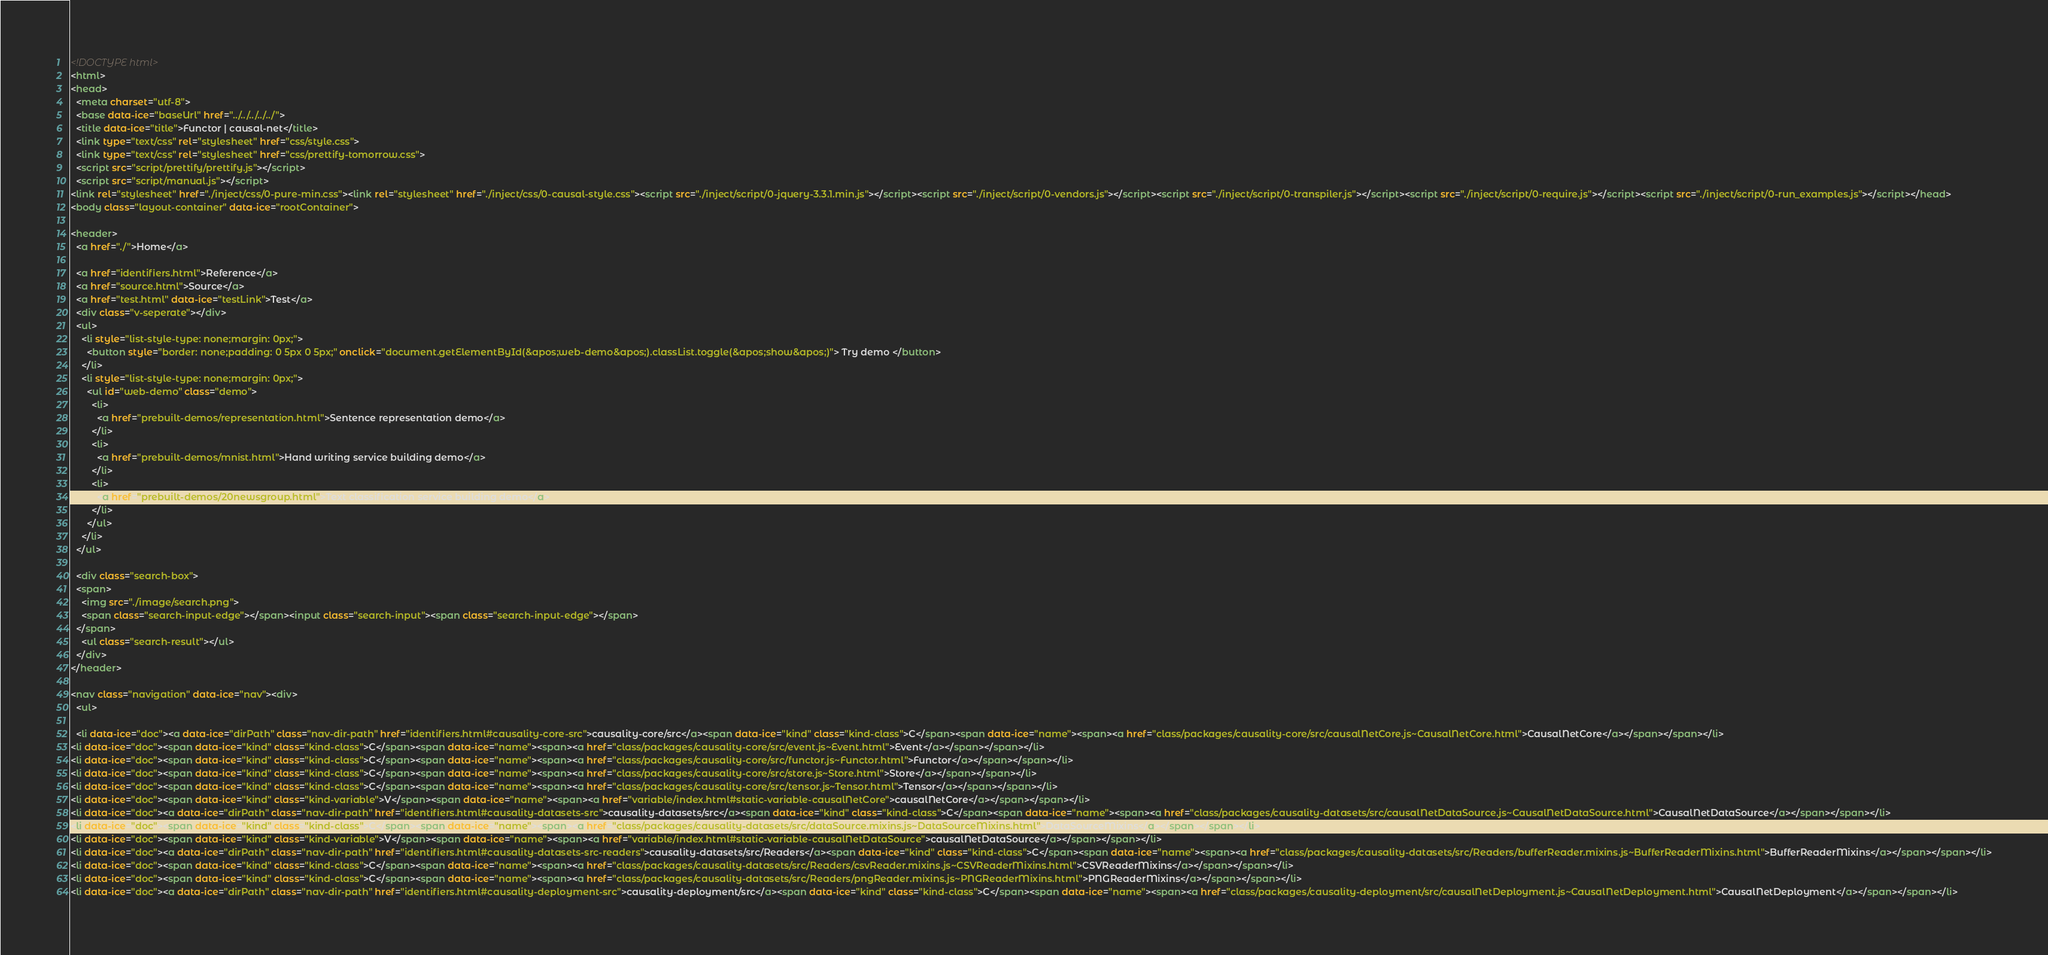<code> <loc_0><loc_0><loc_500><loc_500><_HTML_><!DOCTYPE html>
<html>
<head>
  <meta charset="utf-8">
  <base data-ice="baseUrl" href="../../../../../">
  <title data-ice="title">Functor | causal-net</title>
  <link type="text/css" rel="stylesheet" href="css/style.css">
  <link type="text/css" rel="stylesheet" href="css/prettify-tomorrow.css">
  <script src="script/prettify/prettify.js"></script>
  <script src="script/manual.js"></script>
<link rel="stylesheet" href="./inject/css/0-pure-min.css"><link rel="stylesheet" href="./inject/css/0-causal-style.css"><script src="./inject/script/0-jquery-3.3.1.min.js"></script><script src="./inject/script/0-vendors.js"></script><script src="./inject/script/0-transpiler.js"></script><script src="./inject/script/0-require.js"></script><script src="./inject/script/0-run_examples.js"></script></head>
<body class="layout-container" data-ice="rootContainer">

<header>
  <a href="./">Home</a>
  
  <a href="identifiers.html">Reference</a>
  <a href="source.html">Source</a>
  <a href="test.html" data-ice="testLink">Test</a>
  <div class="v-seperate"></div>
  <ul>
    <li style="list-style-type: none;margin: 0px;">
      <button style="border: none;padding: 0 5px 0 5px;" onclick="document.getElementById(&apos;web-demo&apos;).classList.toggle(&apos;show&apos;)"> Try demo </button>
    </li>
    <li style="list-style-type: none;margin: 0px;">
      <ul id="web-demo" class="demo">
        <li>
          <a href="prebuilt-demos/representation.html">Sentence representation demo</a>
        </li>
        <li>
          <a href="prebuilt-demos/mnist.html">Hand writing service building demo</a>
        </li>
        <li>
          <a href="prebuilt-demos/20newsgroup.html">Text classification service building demo</a>
        </li>
      </ul>    
    </li>
  </ul>
  
  <div class="search-box">
  <span>
    <img src="./image/search.png">
    <span class="search-input-edge"></span><input class="search-input"><span class="search-input-edge"></span>
  </span>
    <ul class="search-result"></ul>
  </div>
</header>

<nav class="navigation" data-ice="nav"><div>
  <ul>
    
  <li data-ice="doc"><a data-ice="dirPath" class="nav-dir-path" href="identifiers.html#causality-core-src">causality-core/src</a><span data-ice="kind" class="kind-class">C</span><span data-ice="name"><span><a href="class/packages/causality-core/src/causalNetCore.js~CausalNetCore.html">CausalNetCore</a></span></span></li>
<li data-ice="doc"><span data-ice="kind" class="kind-class">C</span><span data-ice="name"><span><a href="class/packages/causality-core/src/event.js~Event.html">Event</a></span></span></li>
<li data-ice="doc"><span data-ice="kind" class="kind-class">C</span><span data-ice="name"><span><a href="class/packages/causality-core/src/functor.js~Functor.html">Functor</a></span></span></li>
<li data-ice="doc"><span data-ice="kind" class="kind-class">C</span><span data-ice="name"><span><a href="class/packages/causality-core/src/store.js~Store.html">Store</a></span></span></li>
<li data-ice="doc"><span data-ice="kind" class="kind-class">C</span><span data-ice="name"><span><a href="class/packages/causality-core/src/tensor.js~Tensor.html">Tensor</a></span></span></li>
<li data-ice="doc"><span data-ice="kind" class="kind-variable">V</span><span data-ice="name"><span><a href="variable/index.html#static-variable-causalNetCore">causalNetCore</a></span></span></li>
<li data-ice="doc"><a data-ice="dirPath" class="nav-dir-path" href="identifiers.html#causality-datasets-src">causality-datasets/src</a><span data-ice="kind" class="kind-class">C</span><span data-ice="name"><span><a href="class/packages/causality-datasets/src/causalNetDataSource.js~CausalNetDataSource.html">CausalNetDataSource</a></span></span></li>
<li data-ice="doc"><span data-ice="kind" class="kind-class">C</span><span data-ice="name"><span><a href="class/packages/causality-datasets/src/dataSource.mixins.js~DataSourceMixins.html">DataSourceMixins</a></span></span></li>
<li data-ice="doc"><span data-ice="kind" class="kind-variable">V</span><span data-ice="name"><span><a href="variable/index.html#static-variable-causalNetDataSource">causalNetDataSource</a></span></span></li>
<li data-ice="doc"><a data-ice="dirPath" class="nav-dir-path" href="identifiers.html#causality-datasets-src-readers">causality-datasets/src/Readers</a><span data-ice="kind" class="kind-class">C</span><span data-ice="name"><span><a href="class/packages/causality-datasets/src/Readers/bufferReader.mixins.js~BufferReaderMixins.html">BufferReaderMixins</a></span></span></li>
<li data-ice="doc"><span data-ice="kind" class="kind-class">C</span><span data-ice="name"><span><a href="class/packages/causality-datasets/src/Readers/csvReader.mixins.js~CSVReaderMixins.html">CSVReaderMixins</a></span></span></li>
<li data-ice="doc"><span data-ice="kind" class="kind-class">C</span><span data-ice="name"><span><a href="class/packages/causality-datasets/src/Readers/pngReader.mixins.js~PNGReaderMixins.html">PNGReaderMixins</a></span></span></li>
<li data-ice="doc"><a data-ice="dirPath" class="nav-dir-path" href="identifiers.html#causality-deployment-src">causality-deployment/src</a><span data-ice="kind" class="kind-class">C</span><span data-ice="name"><span><a href="class/packages/causality-deployment/src/causalNetDeployment.js~CausalNetDeployment.html">CausalNetDeployment</a></span></span></li></code> 